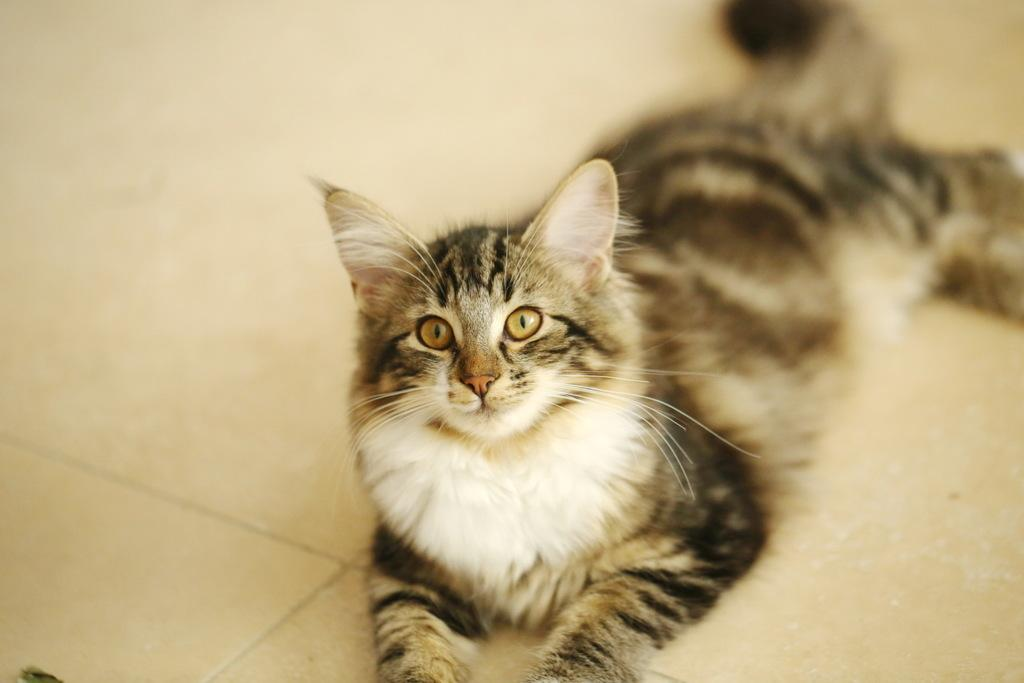What type of animal is in the image? There is a cat in the image. Where is the cat located in the image? The cat is on the floor. Can you describe the cat's appearance? The cat has a white and black color pattern. What is the color of the floor in the image? The floor has a cream color. What type of alarm is present on the wall in the image? There is no alarm present in the image, as the facts provided do not mention any walls or alarms. 